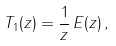<formula> <loc_0><loc_0><loc_500><loc_500>T _ { 1 } ( z ) = \frac { 1 } { z } \, E ( z ) \, ,</formula> 